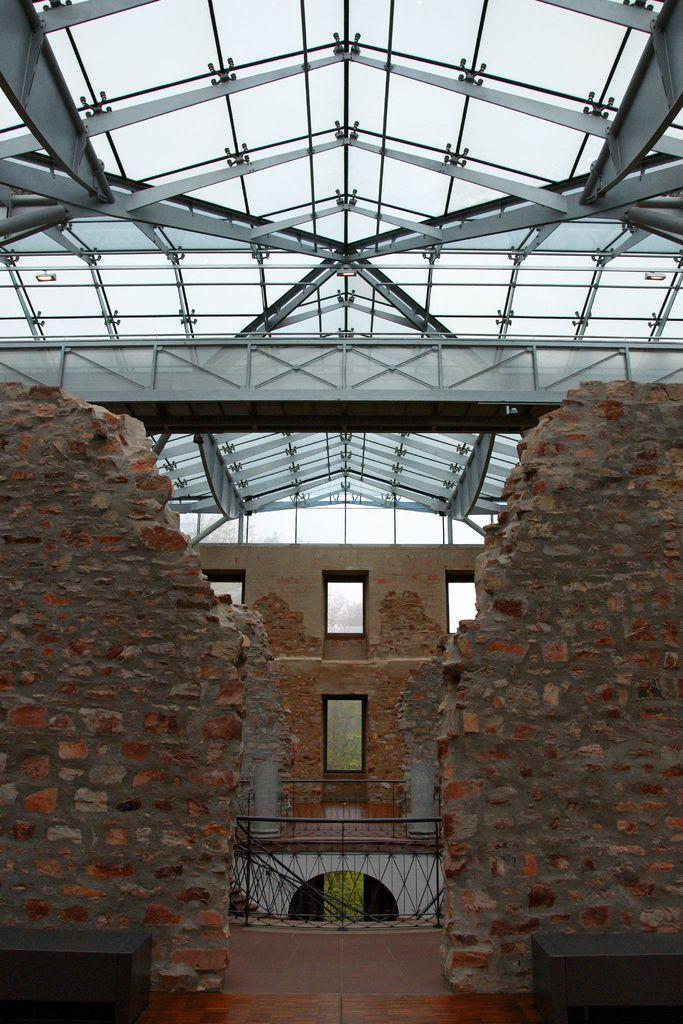Describe this image in one or two sentences. In this image we can see a building, at the top we can see some metal rods, also we can see the fence and the wall, in the background, we can see some trees and the sky. 